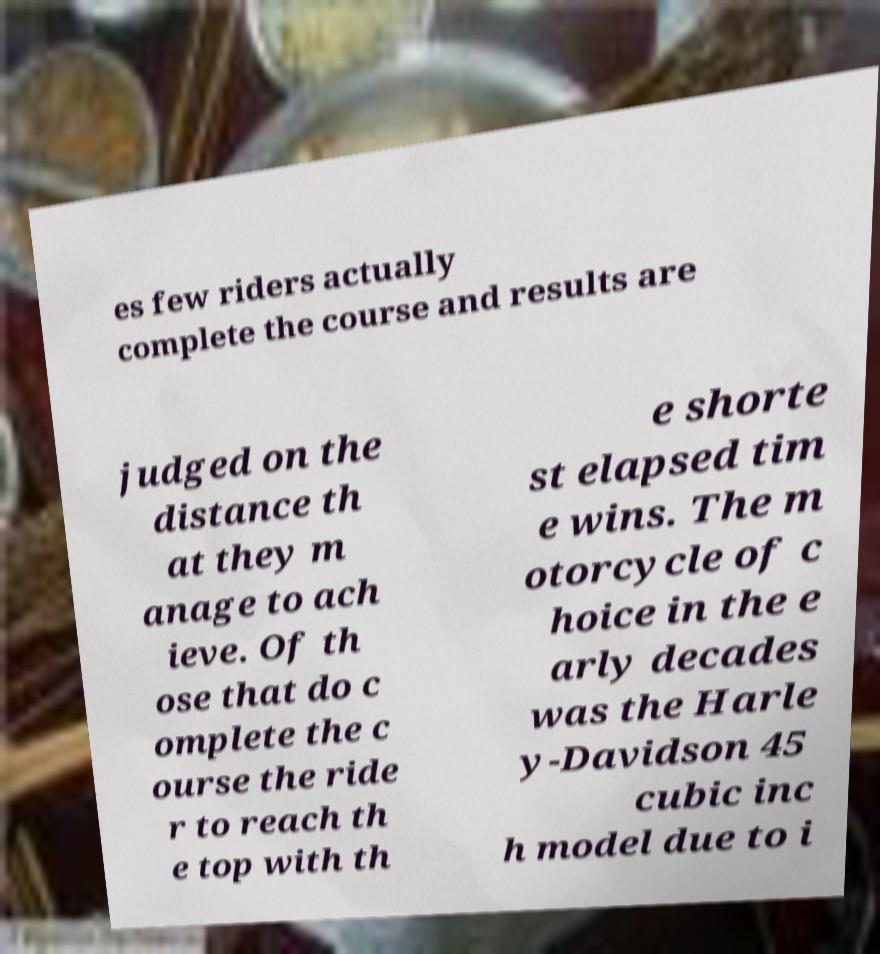Could you assist in decoding the text presented in this image and type it out clearly? es few riders actually complete the course and results are judged on the distance th at they m anage to ach ieve. Of th ose that do c omplete the c ourse the ride r to reach th e top with th e shorte st elapsed tim e wins. The m otorcycle of c hoice in the e arly decades was the Harle y-Davidson 45 cubic inc h model due to i 